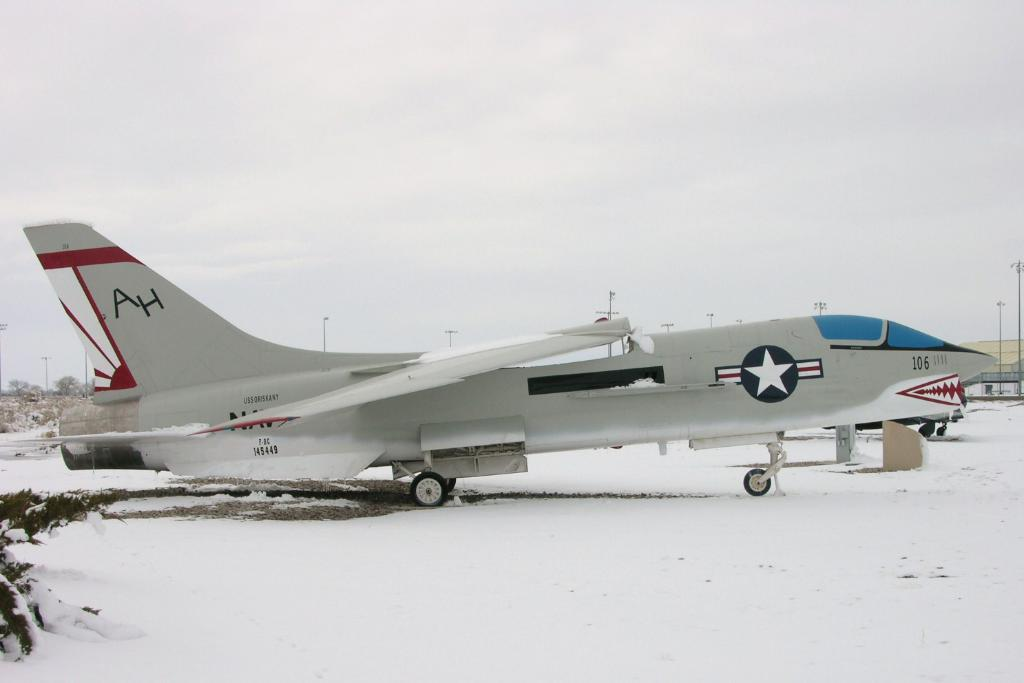<image>
Render a clear and concise summary of the photo. Fighter jet with the number 106  near the front is parked in the snow. 